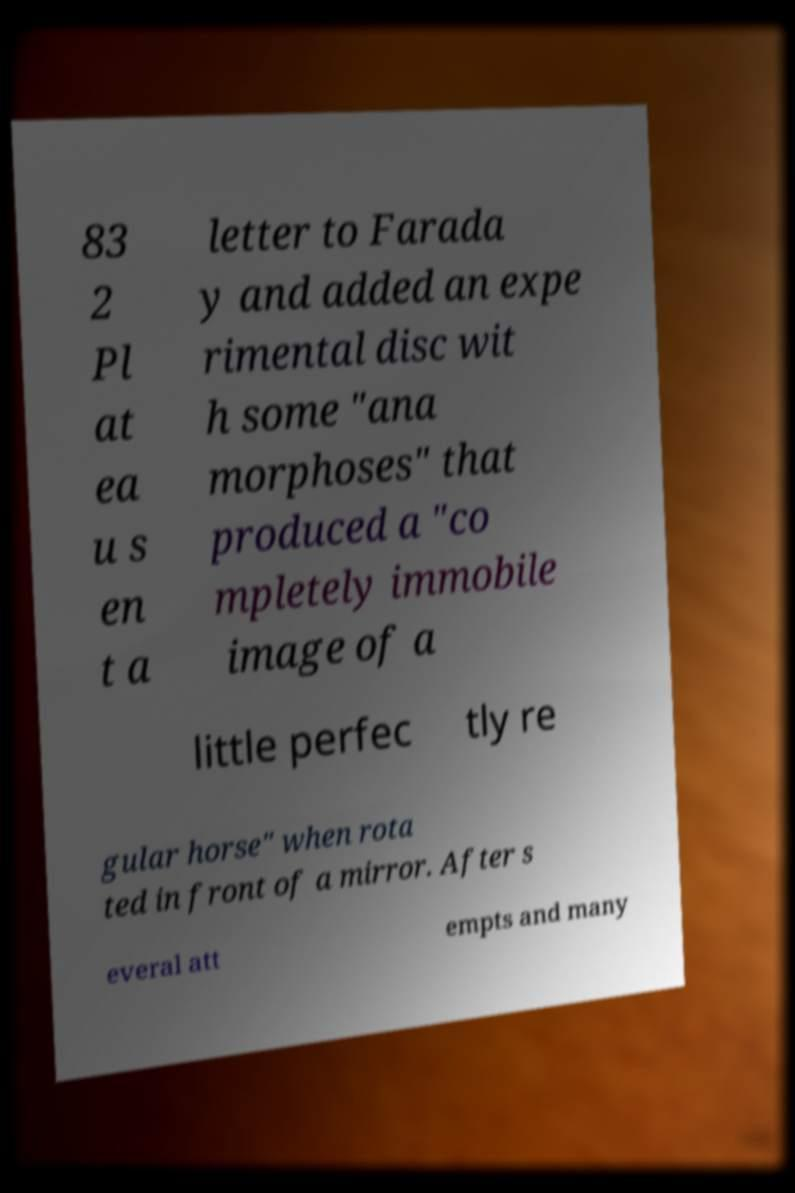Please identify and transcribe the text found in this image. 83 2 Pl at ea u s en t a letter to Farada y and added an expe rimental disc wit h some "ana morphoses" that produced a "co mpletely immobile image of a little perfec tly re gular horse" when rota ted in front of a mirror. After s everal att empts and many 